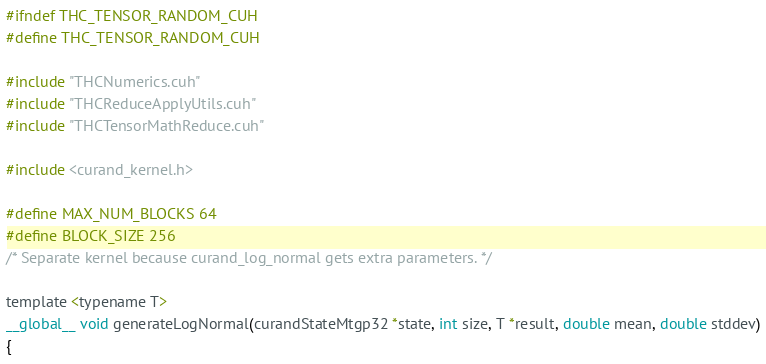Convert code to text. <code><loc_0><loc_0><loc_500><loc_500><_Cuda_>#ifndef THC_TENSOR_RANDOM_CUH
#define THC_TENSOR_RANDOM_CUH

#include "THCNumerics.cuh"
#include "THCReduceApplyUtils.cuh"
#include "THCTensorMathReduce.cuh"

#include <curand_kernel.h>

#define MAX_NUM_BLOCKS 64
#define BLOCK_SIZE 256
/* Separate kernel because curand_log_normal gets extra parameters. */

template <typename T>
__global__ void generateLogNormal(curandStateMtgp32 *state, int size, T *result, double mean, double stddev)
{</code> 